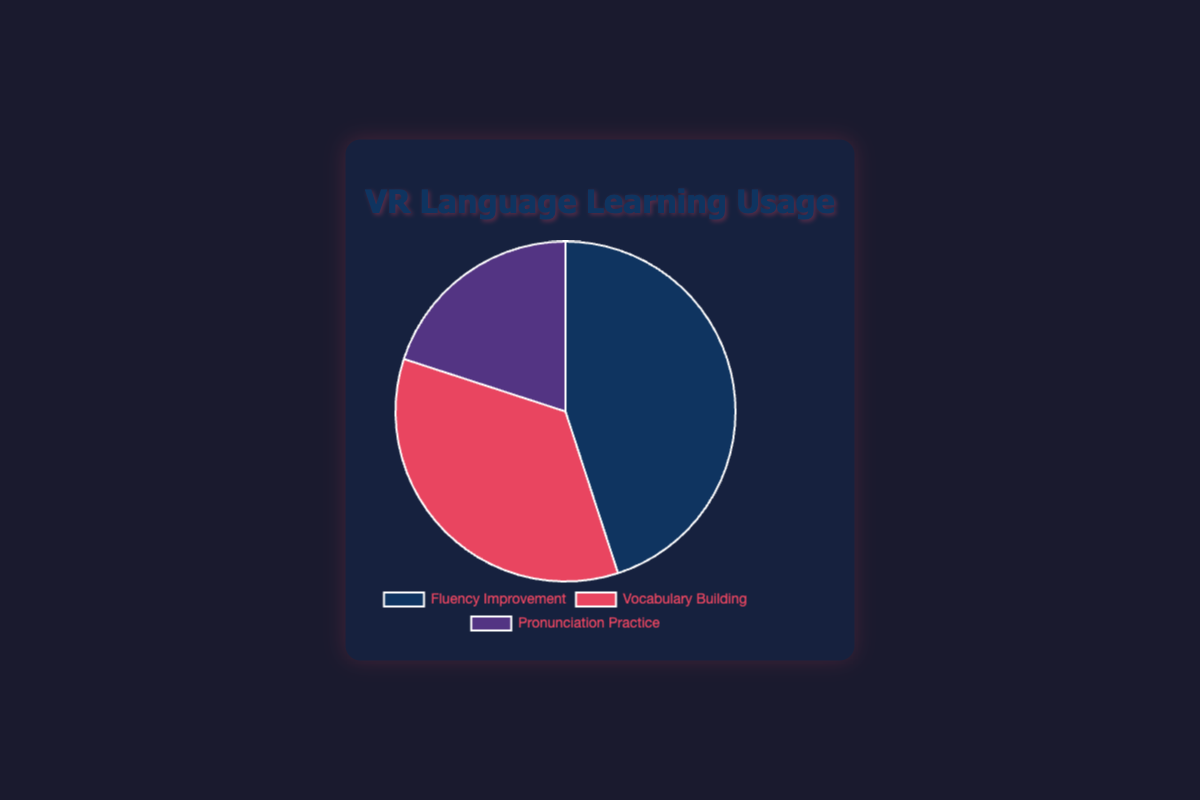Which category accounts for the largest portion of VR usage for language learning? The Pie chart shows that "Fluency Improvement" has the largest segment, making up 45% of the total categories.
Answer: Fluency Improvement Which category has the smallest portion, and what percentage does it represent? The smallest segment in the Pie chart is "Pronunciation Practice," which makes up 20% of the total usage.
Answer: Pronunciation Practice, 20% What is the percentage difference between Vocabulary Building and Pronunciation Practice? Vocabulary Building accounts for 35%, and Pronunciation Practice accounts for 20%. The difference is calculated as 35% - 20% = 15%.
Answer: 15% How do the combined percentages of Vocabulary Building and Pronunciation Practice compare to the percentage of Fluency Improvement? Vocabulary Building and Pronunciation Practice together make up 35% + 20% = 55%, which is 10% more than Fluency Improvement's 45%.
Answer: 10% more Which category is represented by the red segment in the Pie chart? The Pie chart shows Vocabulary Building as the red segment.
Answer: Vocabulary Building By how much does Fluency Improvement exceed Pronunciation Practice in percentage? Fluency Improvement is 45%, and Pronunciation Practice is 20%. The excess amount is 45% - 20% = 25%.
Answer: 25% Which two categories together make up over half of the total VR usage for language learning? Vocabulary Building (35%) and Pronunciation Practice (20%) together make up 55%, more than half of the total pie.
Answer: Vocabulary Building and Pronunciation Practice What is the average percentage of all three categories? Add the percentages: 45% + 35% + 20% = 100%, and then divide by 3. The average is 100% / 3 = 33.33%.
Answer: 33.33% Which color corresponds to the category for Pronunciation Practice? The Pie chart color for Pronunciation Practice is purple.
Answer: purple 